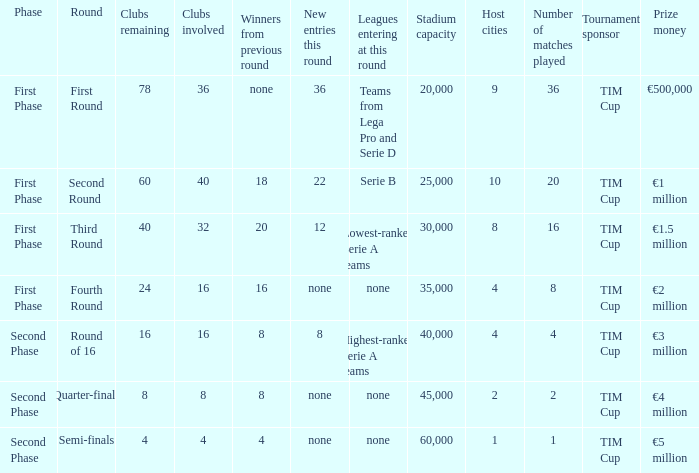When looking at new entries this round and seeing 8; what number in total is there for clubs remaining? 1.0. 